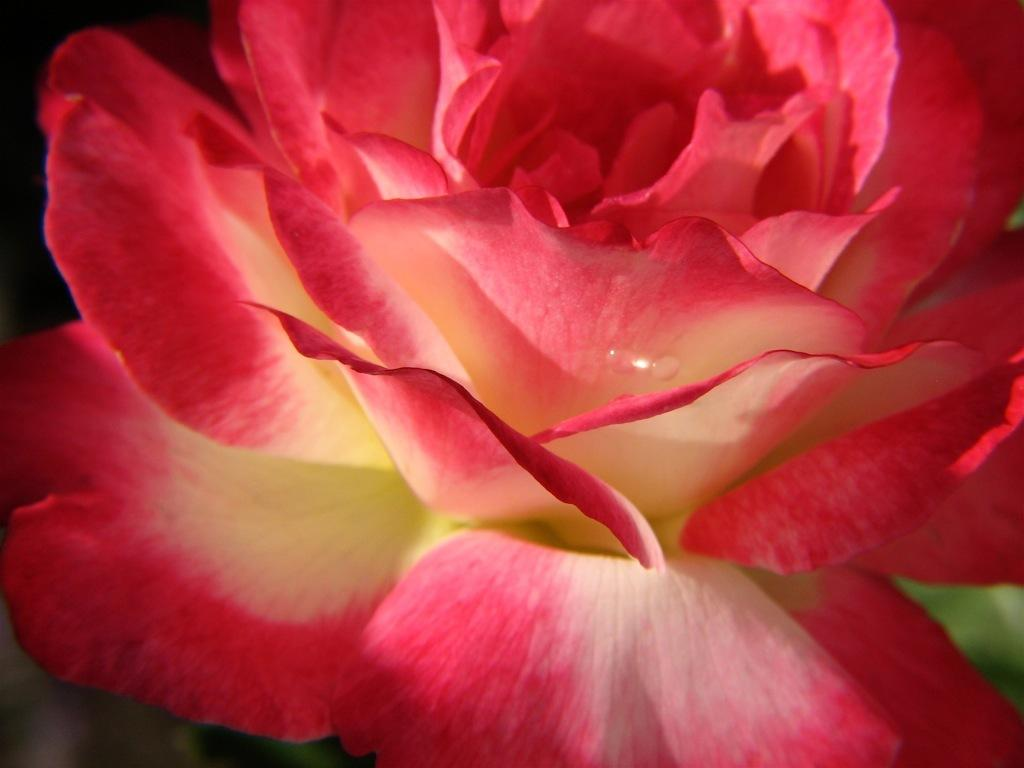What type of flower is in the image? There is a rose flower in the image. What colors can be seen on the rose flower? The rose flower has red, yellow, and cream colors. What colors are present in the background of the image? The background of the image is black and green. What type of news can be heard coming from the rose flower in the image? There is no indication in the image that the rose flower is producing or transmitting any news, as flowers do not have the ability to produce or transmit news. 